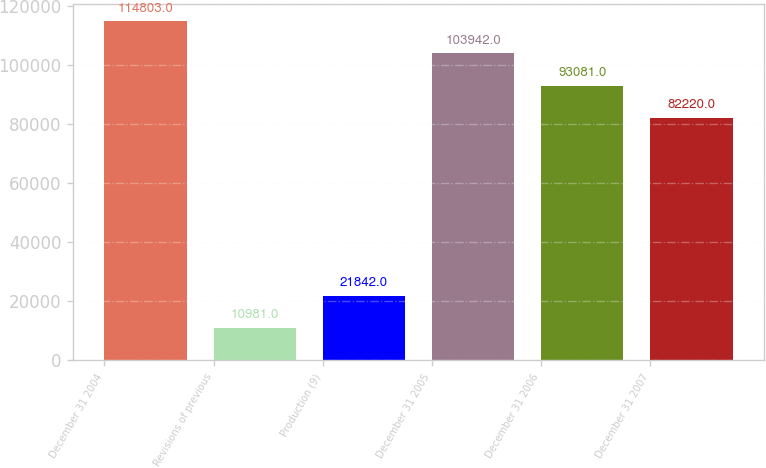Convert chart to OTSL. <chart><loc_0><loc_0><loc_500><loc_500><bar_chart><fcel>December 31 2004<fcel>Revisions of previous<fcel>Production (9)<fcel>December 31 2005<fcel>December 31 2006<fcel>December 31 2007<nl><fcel>114803<fcel>10981<fcel>21842<fcel>103942<fcel>93081<fcel>82220<nl></chart> 